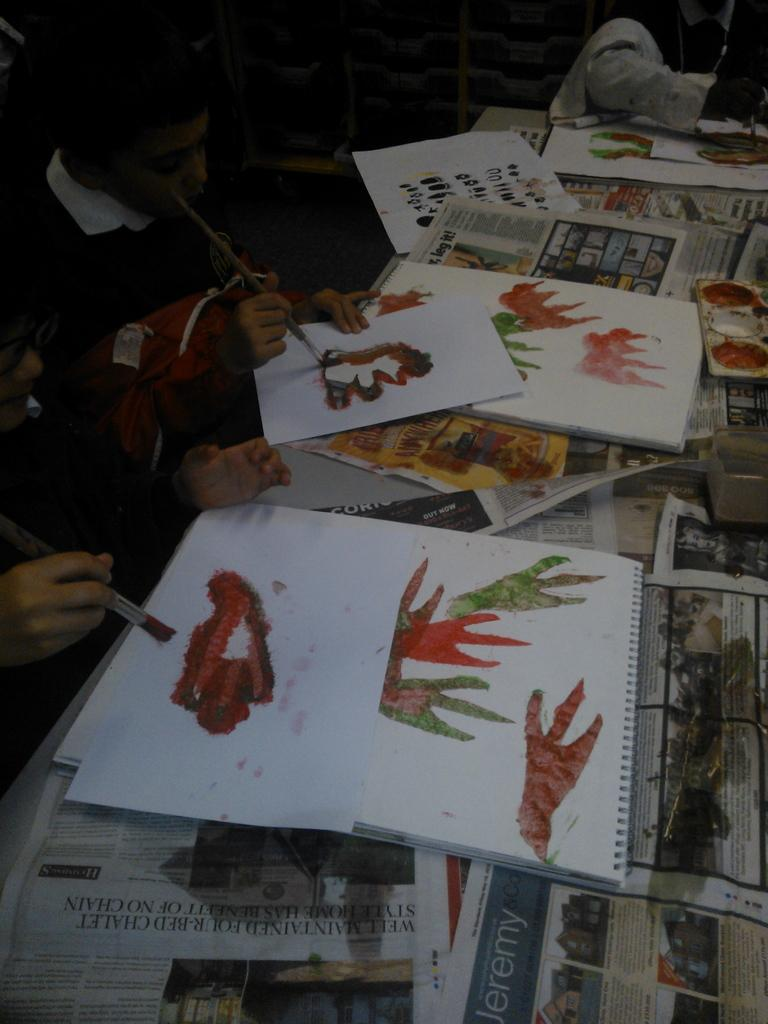What is depicted on the papers in the image? The papers in the image have text and drawings on them. What are the persons on the left side of the image doing? The persons on the left side of the image are drawing. What can be seen in the background of the image? There are objects in the background of the image. What type of form is being filled out by the persons in the image? There is no form present in the image; the persons are drawing on the papers. How does the hot temperature affect the drawing process in the image? The temperature is not mentioned in the image, and therefore its effect on the drawing process cannot be determined. 